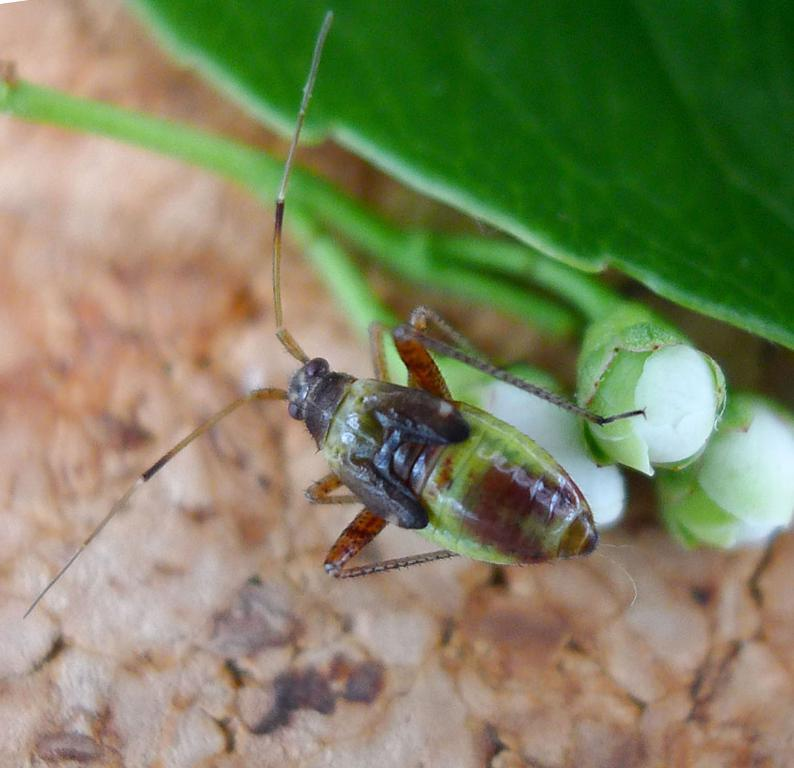What type of creature is in the image? There is an insect in the image. Where is the insect located? The insect is on a bud. What can be seen behind the insect? There is a leaf behind the insect. How many buds are visible in the image? There are buds visible in the image. Can you describe the unspecified object in the image? Unfortunately, the facts provided do not give any details about the unspecified object. What type of prison is depicted in the image? There is no prison present in the image. 